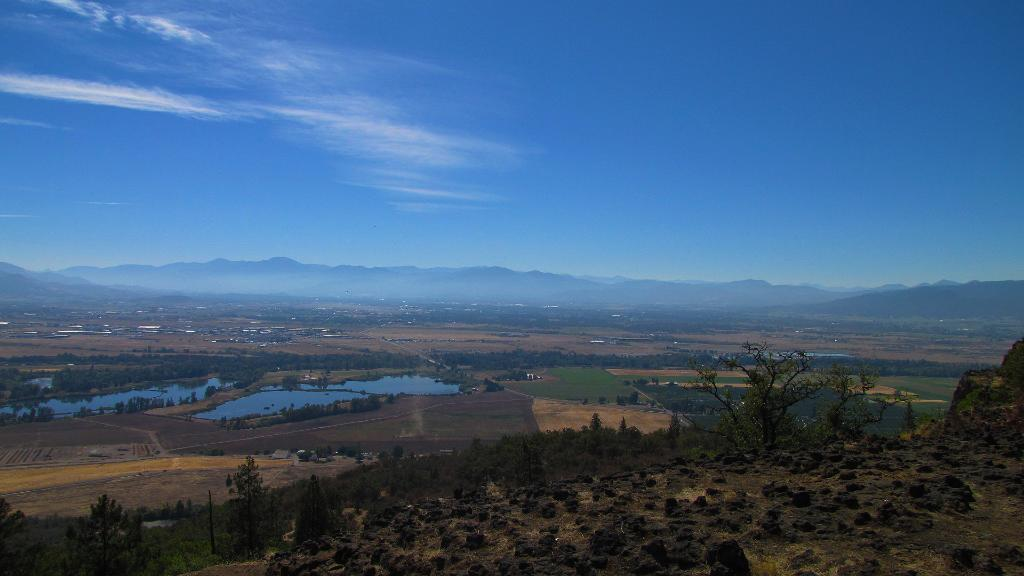What is visible at the top of the image? The sky is visible at the top of the image. What geographical feature can be seen in the middle of the image? There is a hill in the middle of the image. What type of vegetation is present in the image? Trees are present in the image. What natural element can be seen in the image? There is water visible in the image. What celestial bodies are visible in the bottom left of the image? Planets are visible in the bottom left of the image. Where is the seashore located in the image? There is no seashore present in the image. What type of food is being served in the lunchroom in the image? There is no lunchroom present in the image. 